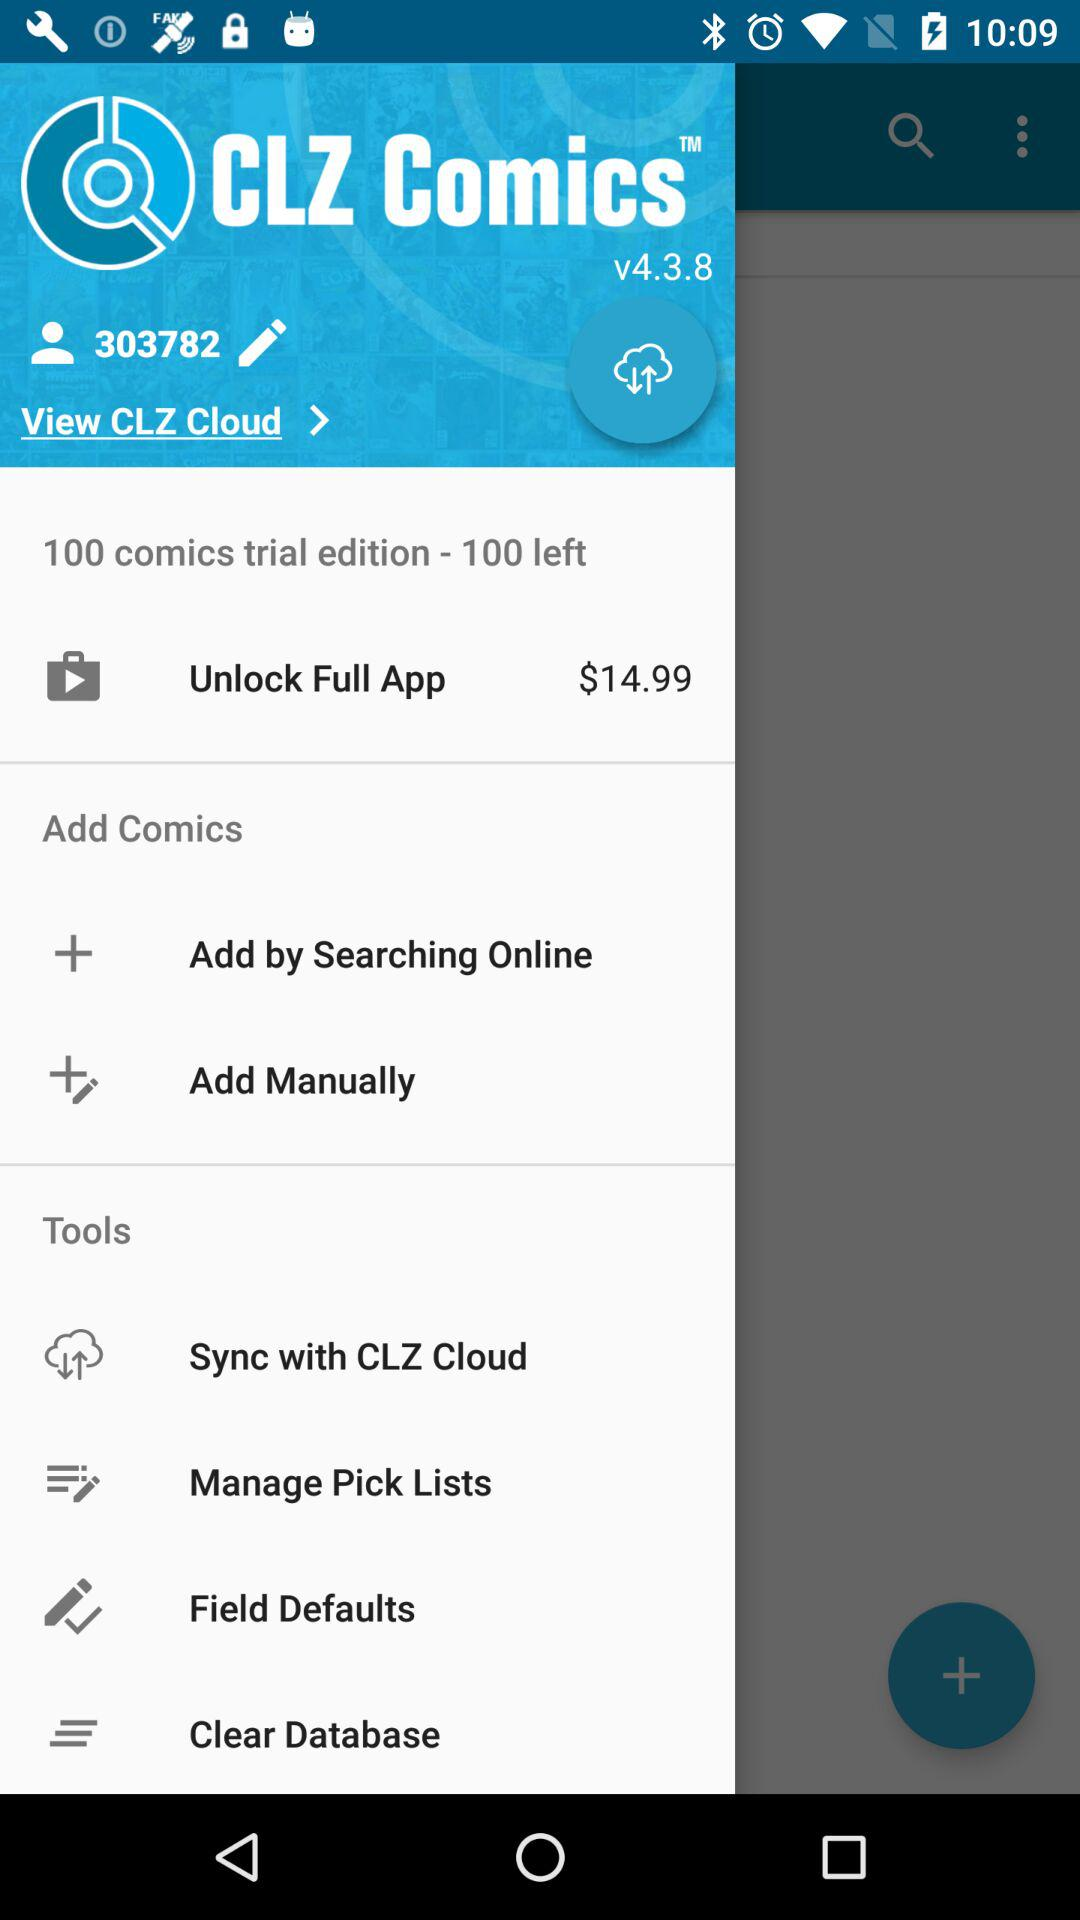How many trial editions are left? There are 100 trial editions left. 